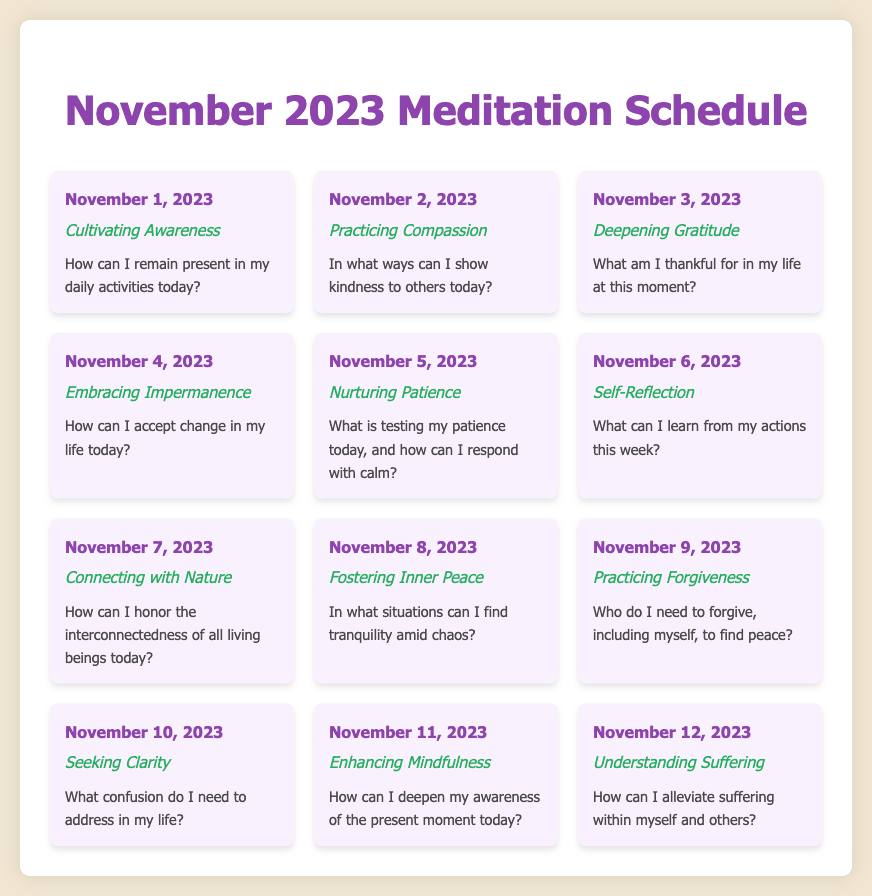What is the title of the document? The title of the document is presented in the header section.
Answer: November 2023 Meditation Schedule How many meditation practices are listed for November 2023? The number of meditation practices can be totalled by counting the entries in the document.
Answer: 12 What is the intention for November 5, 2023? The intention is specifically stated in the meditation card for that day.
Answer: Nurturing Patience What is the reflection question for November 10, 2023? The reflection question is detailed in the meditation card corresponding to that date.
Answer: What confusion do I need to address in my life? Which day focuses on practicing forgiveness? The document outlines specific topics for each day, including forgiveness.
Answer: November 9, 2023 What color is primarily used for the date section? The color of the date section is defined within the styling of each meditation card.
Answer: Purple What is the meditation intention on November 7, 2023? The meditation intention is clearly listed in the respective card for that date.
Answer: Connecting with Nature In which part of the document is the meditation reflection presented? The reflection is provided as part of each meditation card structure within the grid.
Answer: Inside the meditation card How is inner peace described for November 8, 2023? The description is provided in the meditation card for that specific day.
Answer: Fostering Inner Peace 